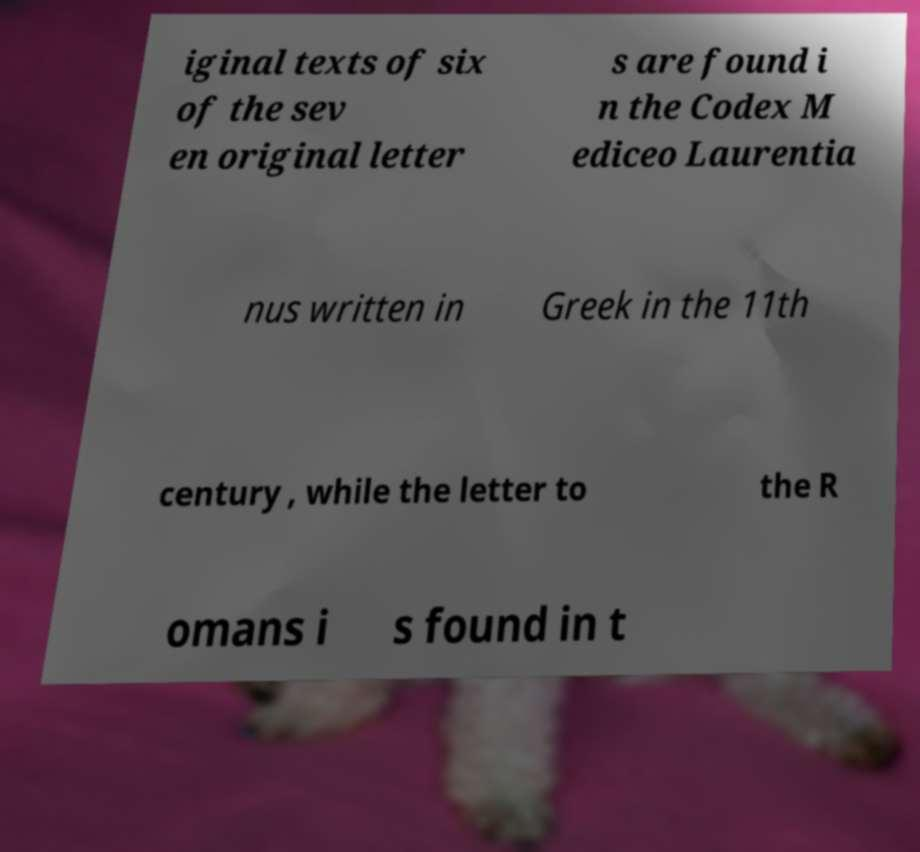For documentation purposes, I need the text within this image transcribed. Could you provide that? iginal texts of six of the sev en original letter s are found i n the Codex M ediceo Laurentia nus written in Greek in the 11th century , while the letter to the R omans i s found in t 